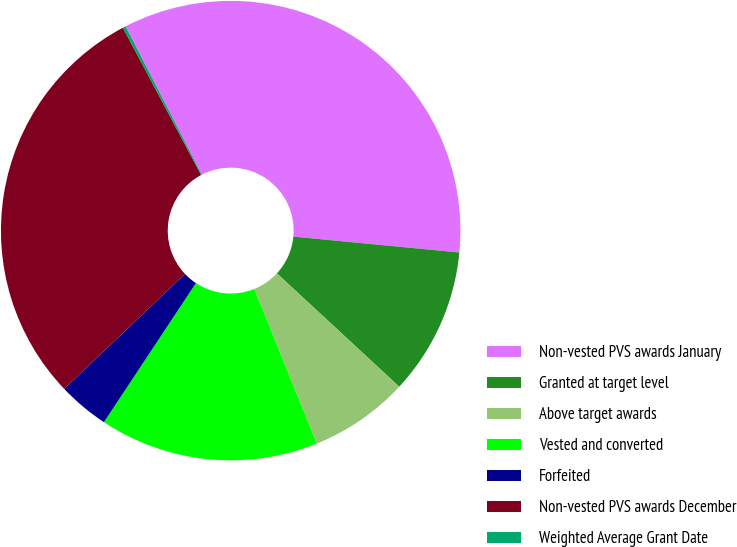Convert chart to OTSL. <chart><loc_0><loc_0><loc_500><loc_500><pie_chart><fcel>Non-vested PVS awards January<fcel>Granted at target level<fcel>Above target awards<fcel>Vested and converted<fcel>Forfeited<fcel>Non-vested PVS awards December<fcel>Weighted Average Grant Date<nl><fcel>34.08%<fcel>10.37%<fcel>6.99%<fcel>15.42%<fcel>3.6%<fcel>29.32%<fcel>0.21%<nl></chart> 